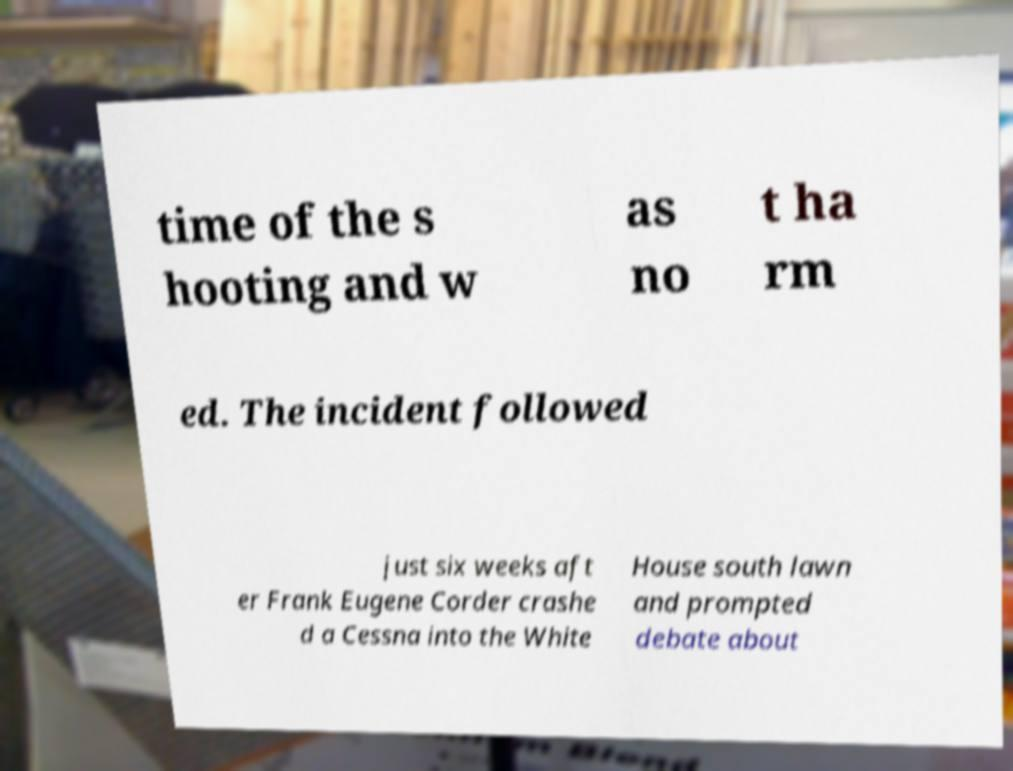What messages or text are displayed in this image? I need them in a readable, typed format. time of the s hooting and w as no t ha rm ed. The incident followed just six weeks aft er Frank Eugene Corder crashe d a Cessna into the White House south lawn and prompted debate about 